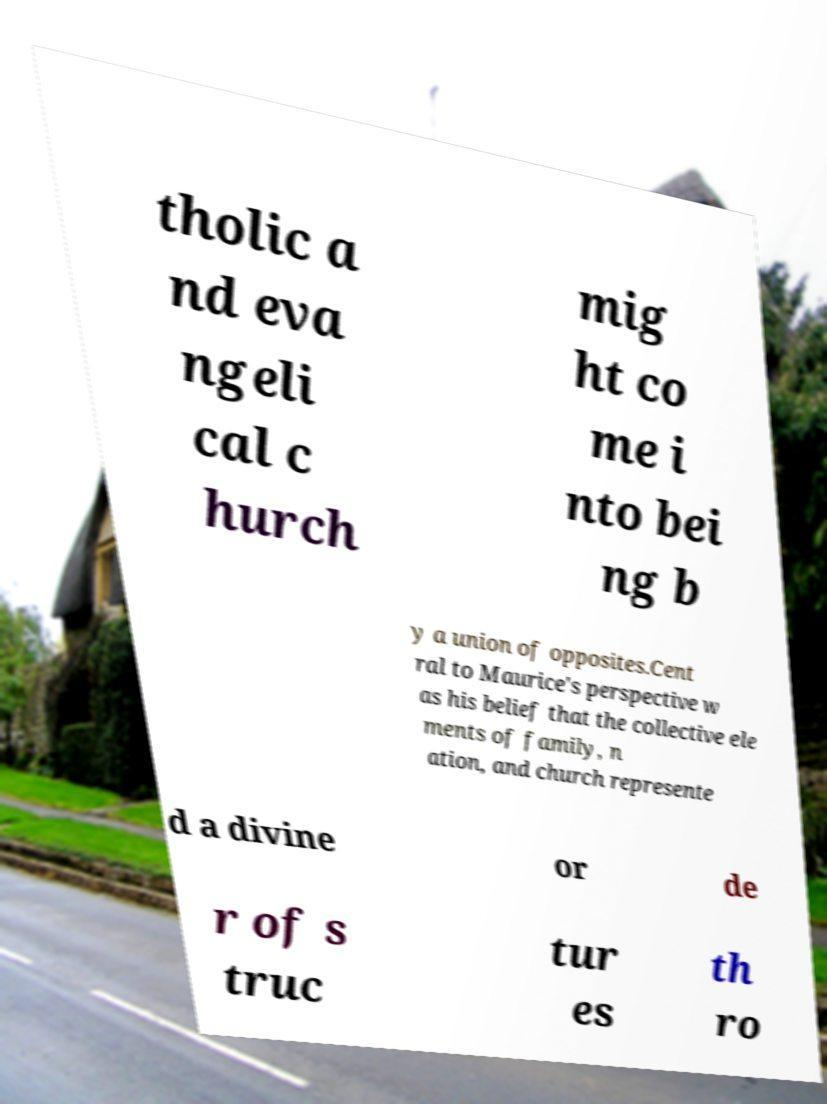Can you accurately transcribe the text from the provided image for me? tholic a nd eva ngeli cal c hurch mig ht co me i nto bei ng b y a union of opposites.Cent ral to Maurice's perspective w as his belief that the collective ele ments of family, n ation, and church represente d a divine or de r of s truc tur es th ro 